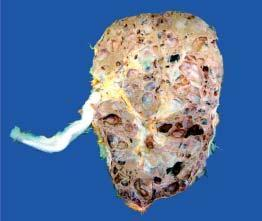re these cysts not communicating with the pelvicalyceal system?
Answer the question using a single word or phrase. Yes 